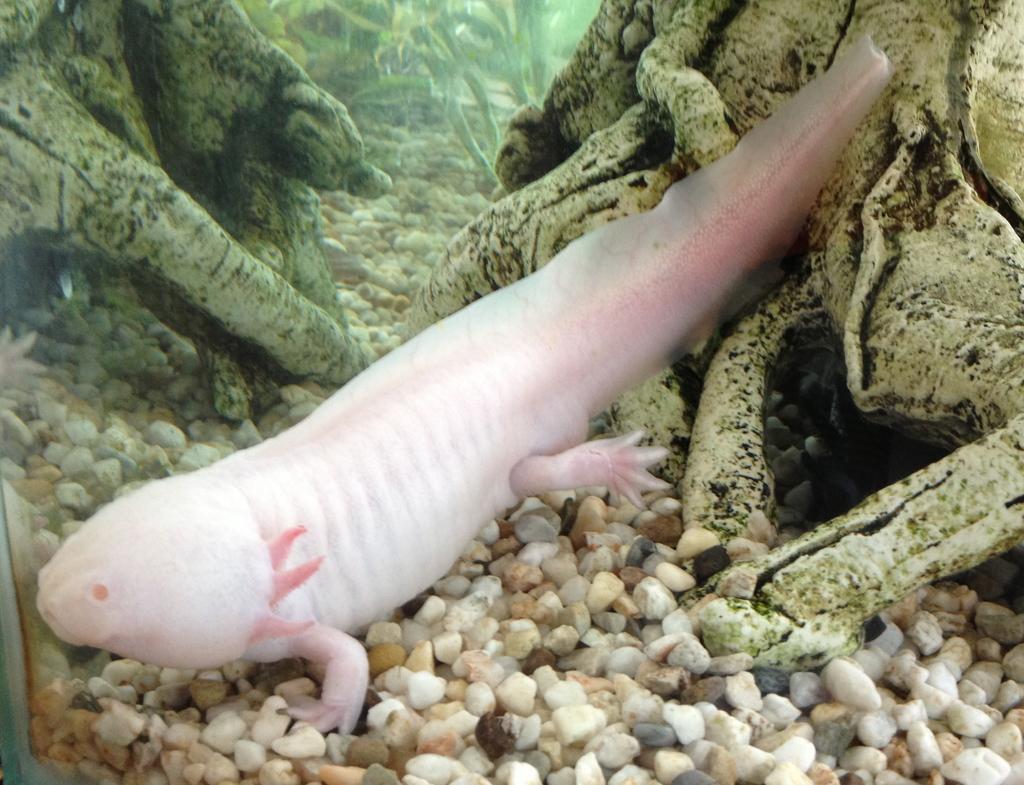In one or two sentences, can you explain what this image depicts? In the center of the image there is a fish underwater. In the background we can see stones and trees. At the bottom there are stones. 